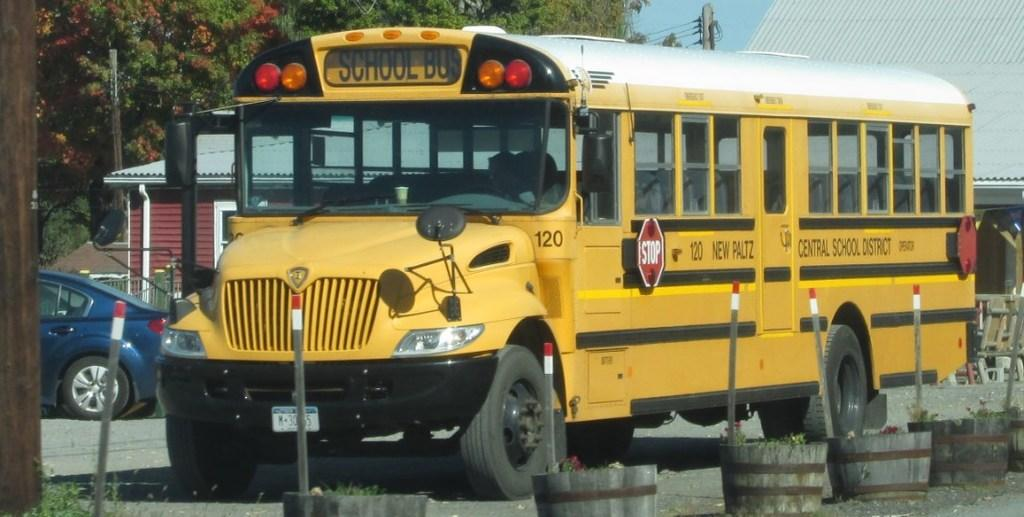What type of vehicle is in the middle of the image? There is a bus in the image. What other type of vehicle is in the middle of the image? There is a car in the image. What can be seen in the background of the image? There are trees and a house in the background of the image. What objects are at the bottom of the image? There are plant pots at the bottom of the image. What type of liquid is being poured out of the bus in the image? There is no liquid being poured out of the bus in the image; it is a stationary vehicle. 